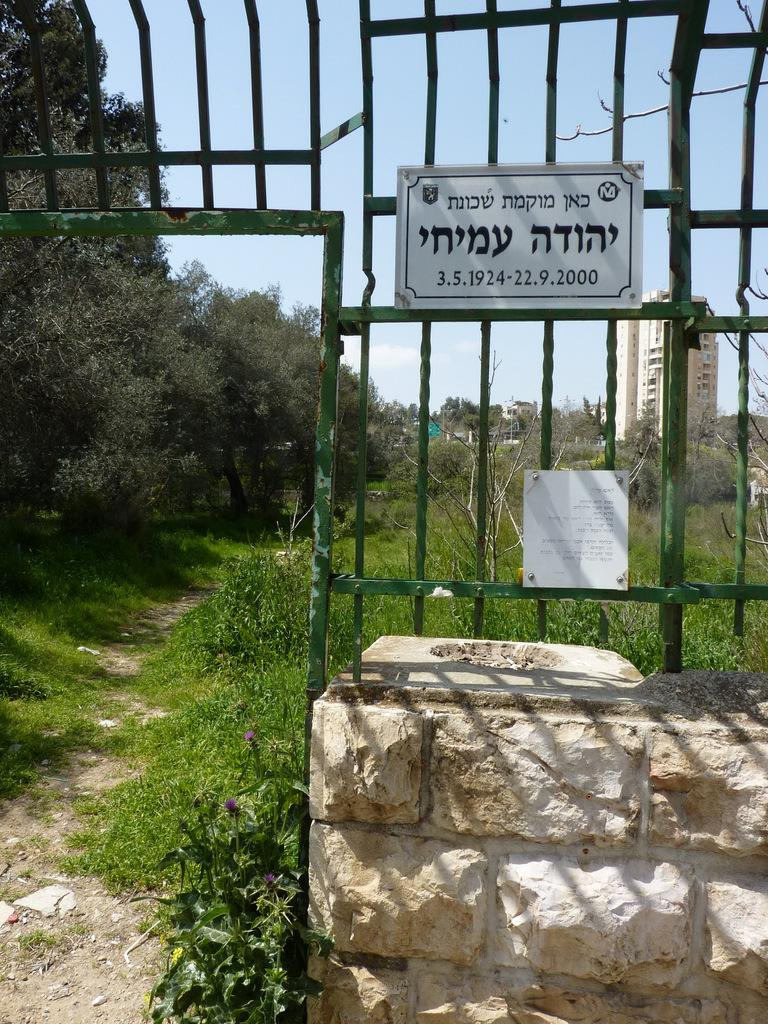What object is present in the image that contains a name? There is a name plate in the image. Where is the name plate located? The name plate is on a metal railing. What is the metal railing attached to? The metal railing is on a wall. What type of vegetation can be seen in the image? There are trees and plants visible in the image. What type of structures can be seen in the image? There are buildings visible in the image. How many attempts were made to feed the horses in the image? There are no horses present in the image, so it is not possible to determine the number of attempts made to feed them. 